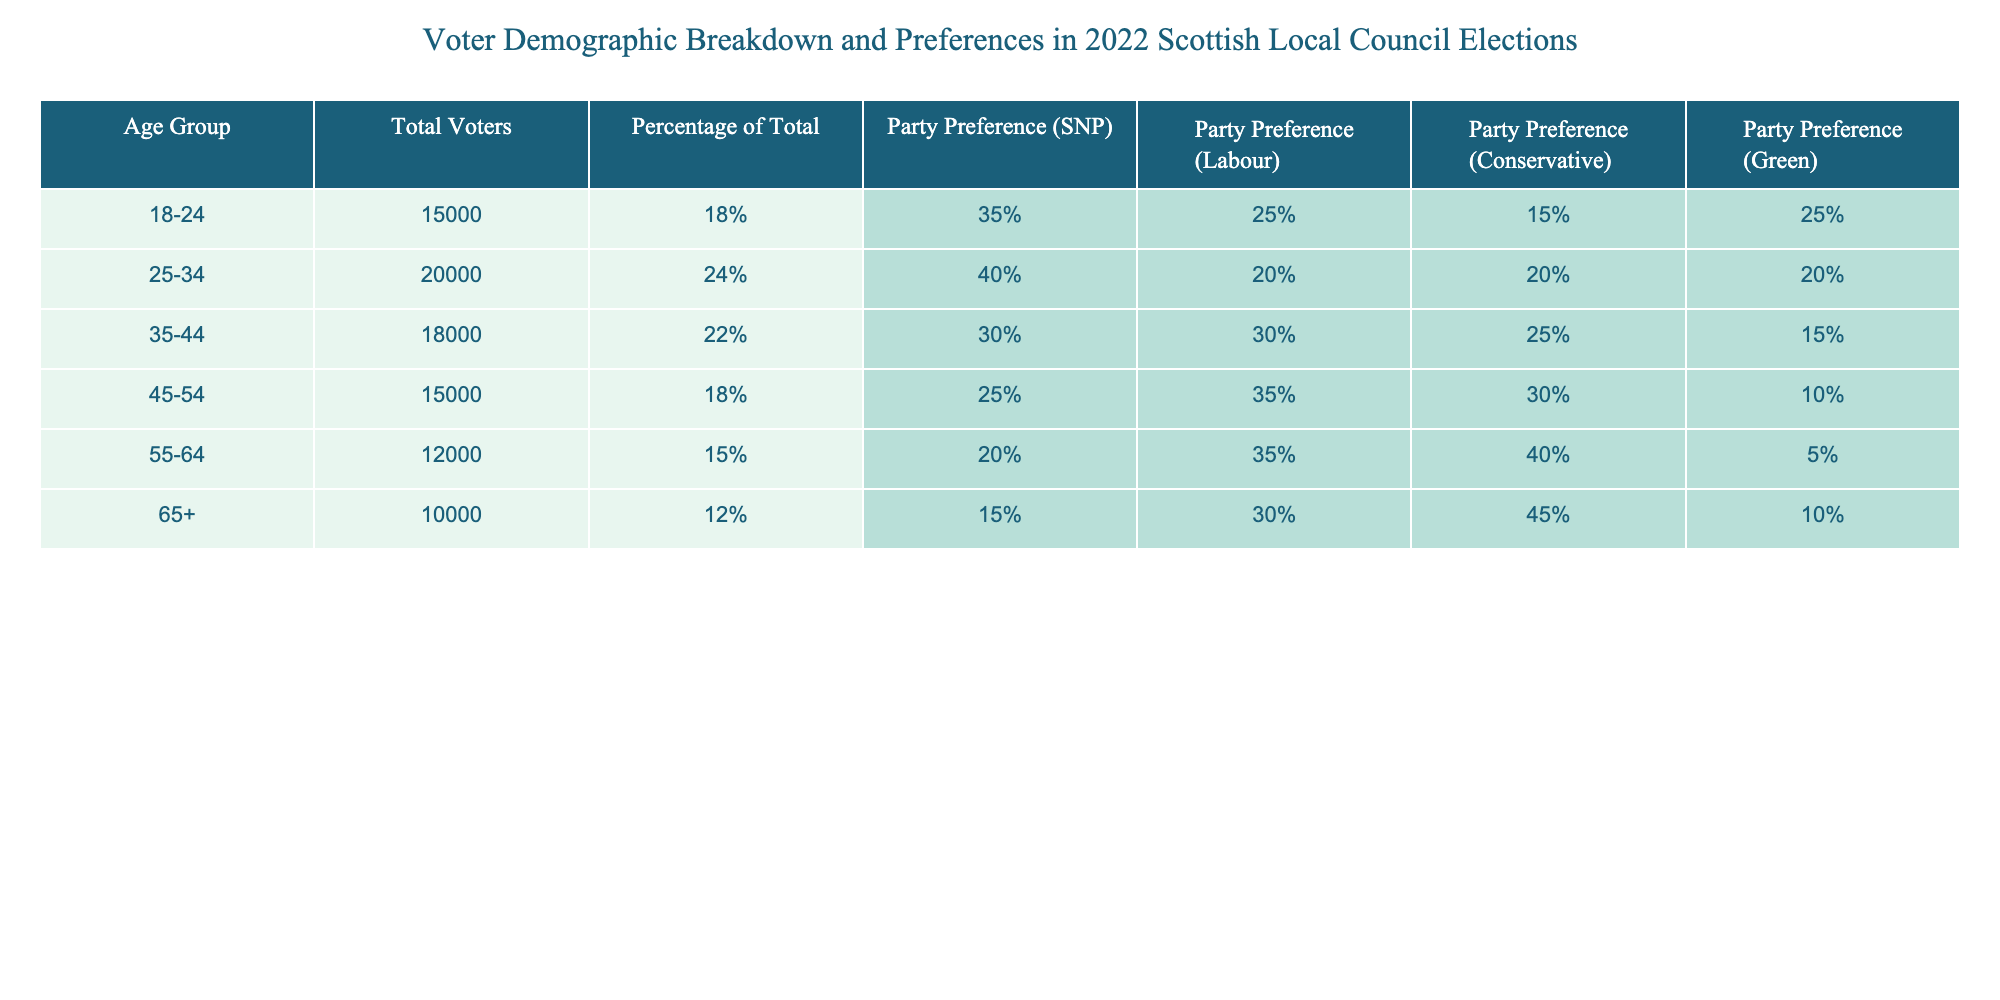What is the total number of voters in the 25-34 age group? The table shows that the total number of voters in the 25-34 age group is listed directly under the "Total Voters" column. It states that there are 20000 voters.
Answer: 20000 Which age group has the highest preference for the SNP? By looking at the "Party Preference (SNP)" column, the preferences for the SNP in each age group are 35% for 18-24, 40% for 25-34, 30% for 35-44, 25% for 45-54, 20% for 55-64, and 15% for 65+. The 25-34 age group has the highest preference at 40%.
Answer: 25-34 Is there any age group in which the Conservative party has more than 40% of the preference? Reviewing the "Party Preference (Conservative)" column, we see that the only age group with a preference of 40% or higher is the 55-64 age group, which has 40%. Thus, the statement is true.
Answer: Yes What is the difference in total voters between the 35-44 age group and the 65+ age group? The total voters in the 35-44 age group is 18000, and for the 65+ age group, it is 10000. Subtracting these values, 18000 - 10000 gives us a difference of 8000 total voters.
Answer: 8000 Which party has the lowest preference among voters aged 55-64? By checking the "Party Preference" columns for the 55-64 age group, we see the percentages are 20% for SNP, 35% for Labour, 40% for Conservative, and 5% for Green. The Green party has the lowest preference at 5%.
Answer: Green What is the average percentage preference for Labour across all age groups listed? The percentages for Labour across the age groups are 25% (18-24), 20% (25-34), 30% (35-44), 35% (45-54), 35% (55-64), and 30% (65+). Adding these percentages gives 25 + 20 + 30 + 35 + 35 + 30 = 175. Dividing this by the number of age groups (6), we find the average is 175 / 6, which equals approximately 29.17%.
Answer: 29.17% In which age group does the percentage of Green party preference drop below 10%? Inspecting the "Party Preference (Green)" column reveals that the only age group with a preference percentage below 10% is the 55-64 age group, which has only 5%.
Answer: 55-64 Is the total voter turnout significantly decreasing as age increases? Looking at the "Total Voters" column, there is a noticeable decrease in the number of voters from the youngest age group (15000 in 18-24) to the oldest age group (10000 in 65+). There is a specific trend where the numbers decrease at some ages. This shows a significant decline overall in voter turnout with increasing age.
Answer: Yes 